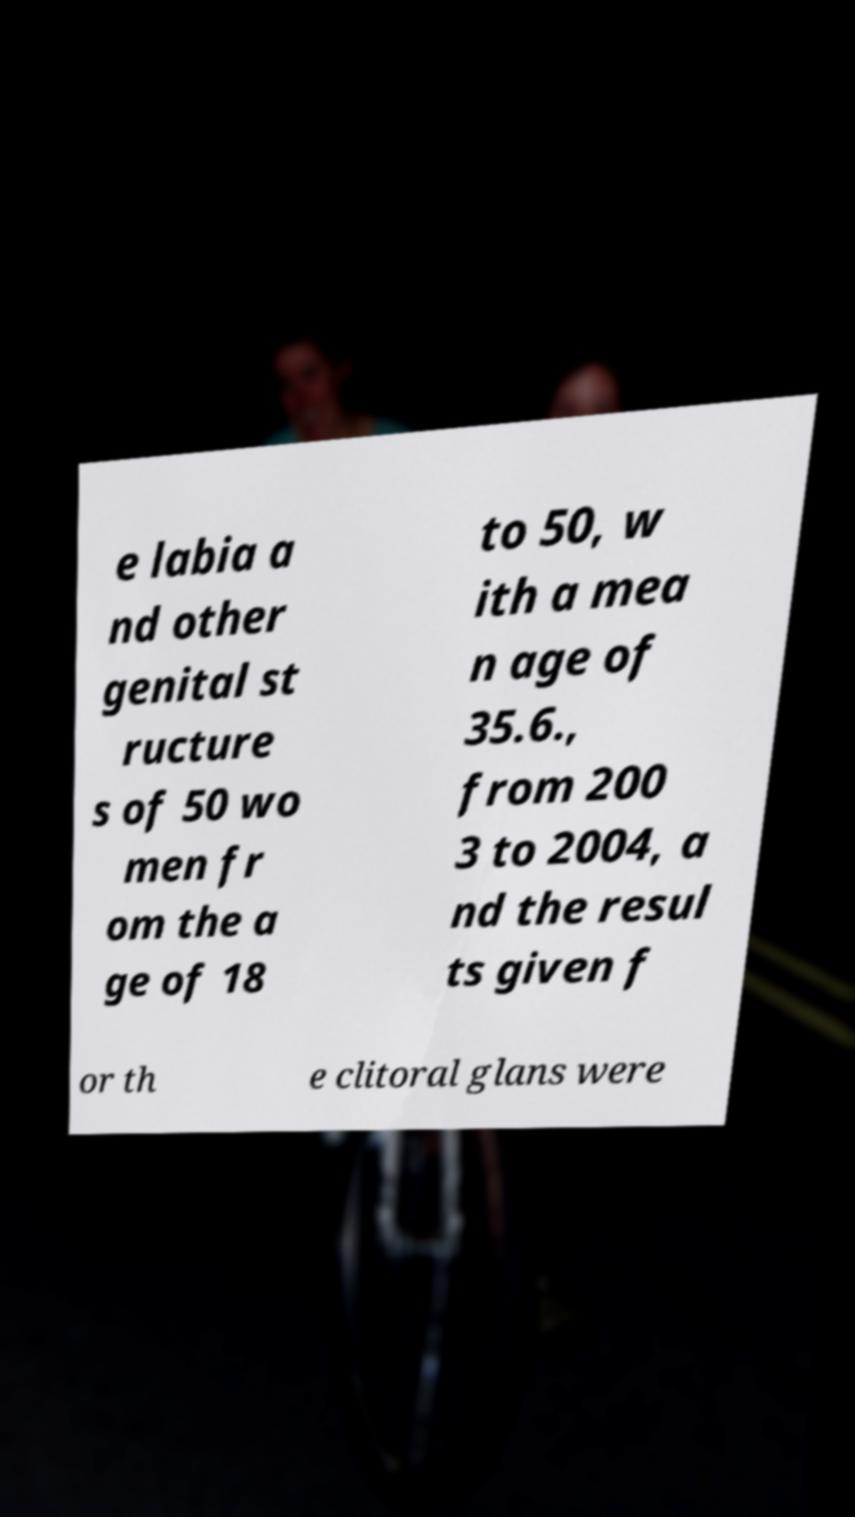What messages or text are displayed in this image? I need them in a readable, typed format. e labia a nd other genital st ructure s of 50 wo men fr om the a ge of 18 to 50, w ith a mea n age of 35.6., from 200 3 to 2004, a nd the resul ts given f or th e clitoral glans were 